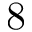Convert formula to latex. <formula><loc_0><loc_0><loc_500><loc_500>8</formula> 